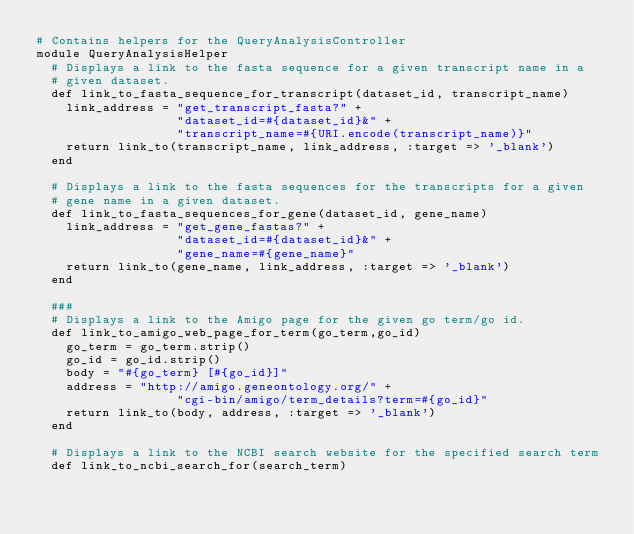Convert code to text. <code><loc_0><loc_0><loc_500><loc_500><_Ruby_># Contains helpers for the QueryAnalysisController
module QueryAnalysisHelper  
  # Displays a link to the fasta sequence for a given transcript name in a 
  # given dataset.
  def link_to_fasta_sequence_for_transcript(dataset_id, transcript_name)
    link_address = "get_transcript_fasta?" +
                   "dataset_id=#{dataset_id}&" +
                   "transcript_name=#{URI.encode(transcript_name)}"
    return link_to(transcript_name, link_address, :target => '_blank')
  end
  
  # Displays a link to the fasta sequences for the transcripts for a given 
  # gene name in a given dataset.
  def link_to_fasta_sequences_for_gene(dataset_id, gene_name)
    link_address = "get_gene_fastas?" +
                   "dataset_id=#{dataset_id}&" +
                   "gene_name=#{gene_name}"
    return link_to(gene_name, link_address, :target => '_blank')
  end
  
  ###
  # Displays a link to the Amigo page for the given go term/go id.
  def link_to_amigo_web_page_for_term(go_term,go_id)
    go_term = go_term.strip()
    go_id = go_id.strip()
    body = "#{go_term} [#{go_id}]"
    address = "http://amigo.geneontology.org/" +
                   "cgi-bin/amigo/term_details?term=#{go_id}"
    return link_to(body, address, :target => '_blank')
  end
  
  # Displays a link to the NCBI search website for the specified search term
  def link_to_ncbi_search_for(search_term)</code> 